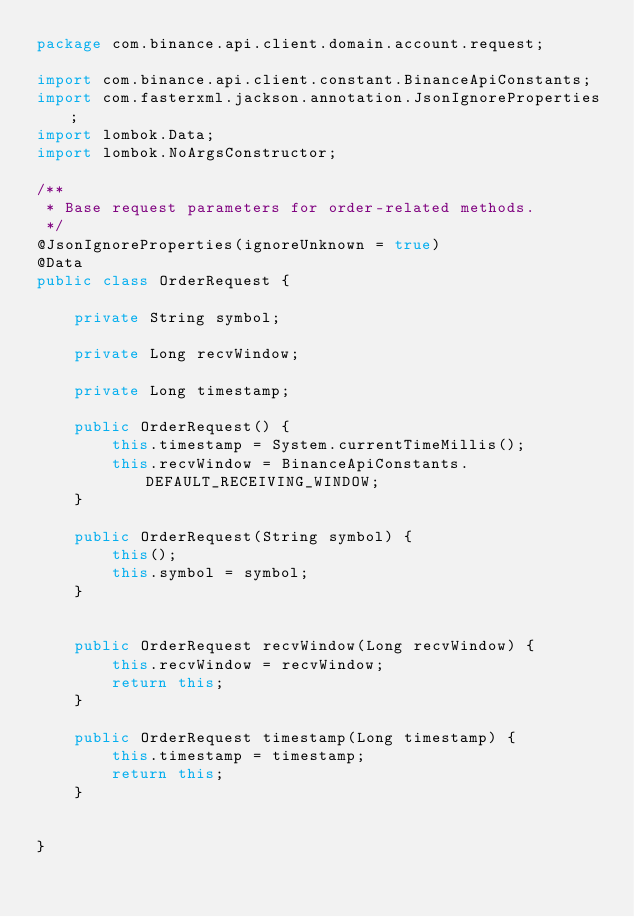<code> <loc_0><loc_0><loc_500><loc_500><_Java_>package com.binance.api.client.domain.account.request;

import com.binance.api.client.constant.BinanceApiConstants;
import com.fasterxml.jackson.annotation.JsonIgnoreProperties;
import lombok.Data;
import lombok.NoArgsConstructor;

/**
 * Base request parameters for order-related methods.
 */
@JsonIgnoreProperties(ignoreUnknown = true)
@Data
public class OrderRequest {

    private String symbol;

    private Long recvWindow;

    private Long timestamp;

    public OrderRequest() {
        this.timestamp = System.currentTimeMillis();
        this.recvWindow = BinanceApiConstants.DEFAULT_RECEIVING_WINDOW;
    }

    public OrderRequest(String symbol) {
        this();
        this.symbol = symbol;
    }


    public OrderRequest recvWindow(Long recvWindow) {
        this.recvWindow = recvWindow;
        return this;
    }

    public OrderRequest timestamp(Long timestamp) {
        this.timestamp = timestamp;
        return this;
    }


}
</code> 